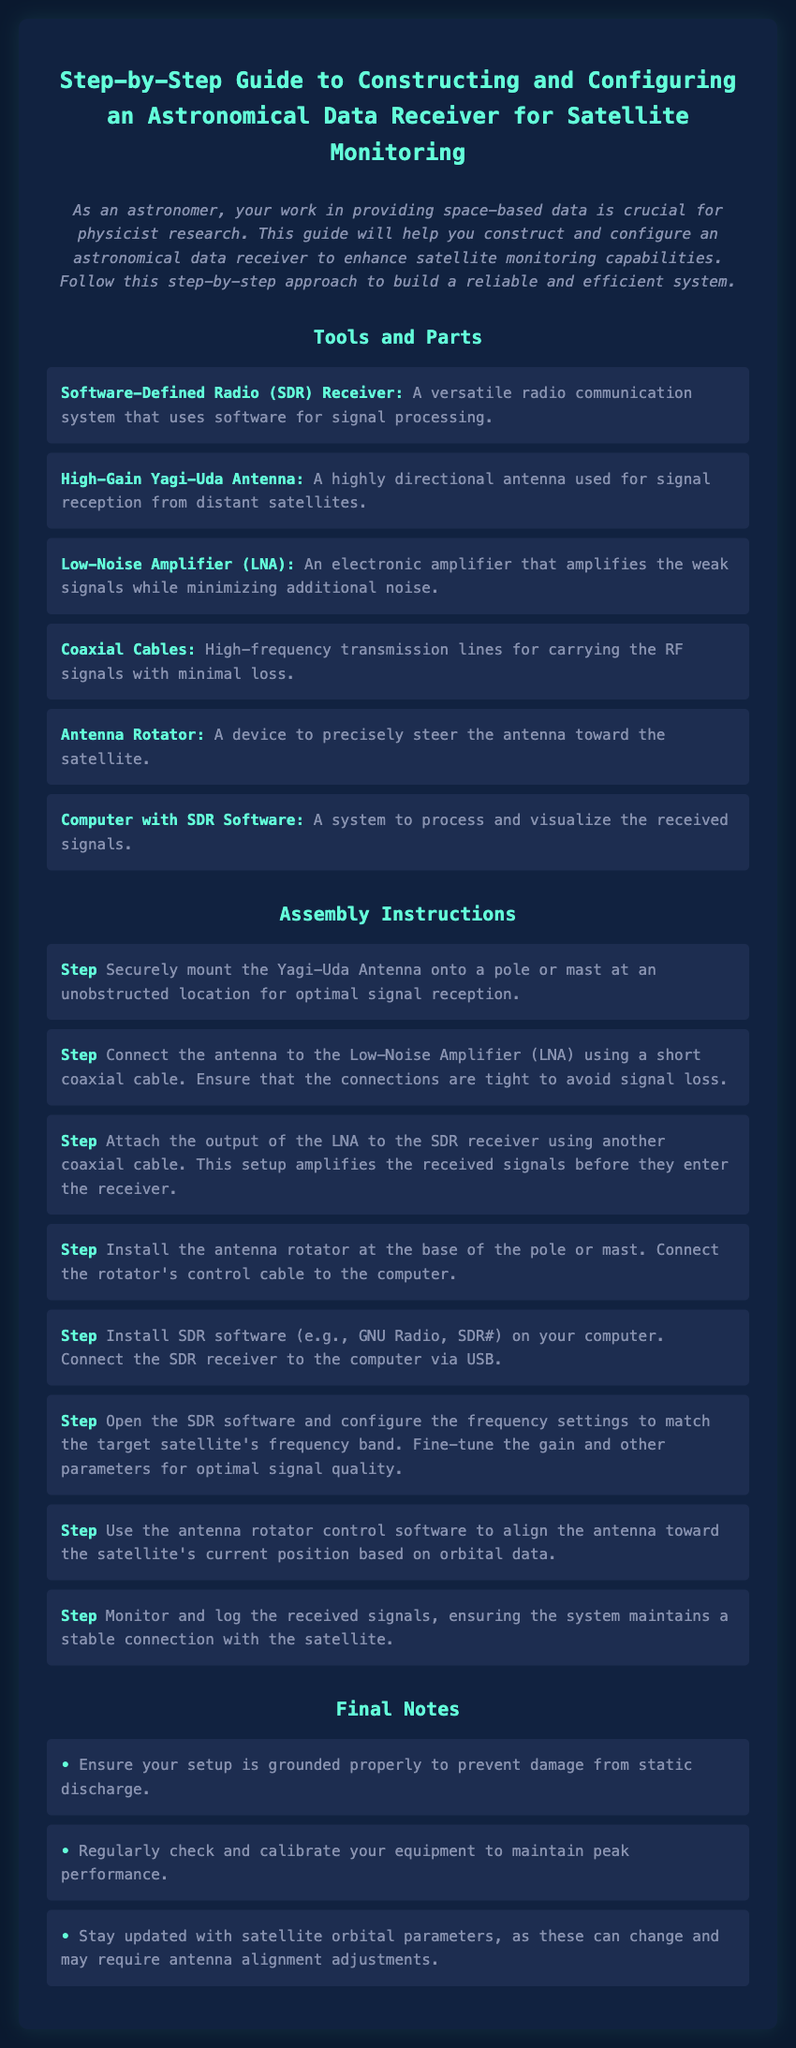What is the main purpose of this guide? The guide aims to help astronomers construct and configure an astronomical data receiver to enhance satellite monitoring capabilities.
Answer: Enhance satellite monitoring capabilities What is the first tool listed in the tools and parts section? The first tool mentioned in the document is the Software-Defined Radio (SDR) Receiver.
Answer: Software-Defined Radio (SDR) Receiver How many steps are provided in the assembly instructions? There are eight steps outlined in the assembly instructions for constructing the data receiver.
Answer: Eight What type of antenna is used in this assembly? The document specifies the use of a High-Gain Yagi-Uda Antenna for signal reception.
Answer: High-Gain Yagi-Uda Antenna Which software is suggested for processing and visualizing received signals? The guide mentions GNU Radio and SDR# as options for SDR software.
Answer: GNU Radio, SDR# What should be monitored to ensure a stable connection with the satellite? The received signals must be monitored and logged to ensure stable connectivity.
Answer: Received signals What is recommended for calibrating equipment? Regular checks and calibration of equipment are advised to maintain peak performance.
Answer: Regular checks and calibration What is the last note regarding the equipment setup? The last note emphasizes ensuring the setup's proper grounding to prevent static discharge damage.
Answer: Proper grounding 